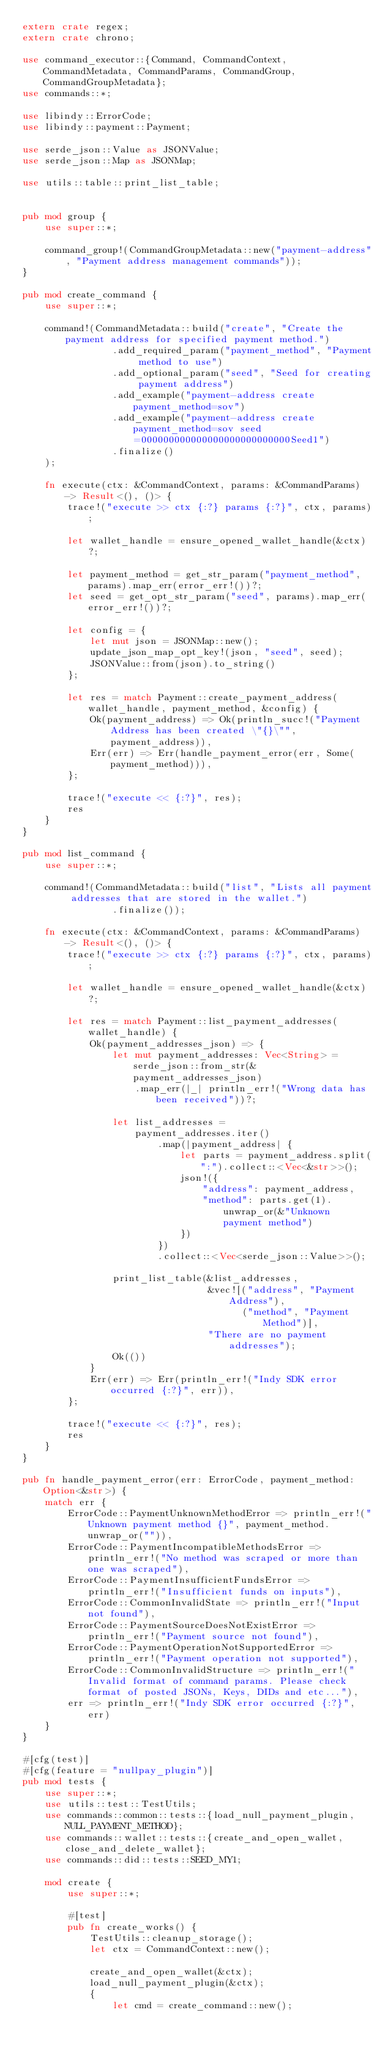Convert code to text. <code><loc_0><loc_0><loc_500><loc_500><_Rust_>extern crate regex;
extern crate chrono;

use command_executor::{Command, CommandContext, CommandMetadata, CommandParams, CommandGroup, CommandGroupMetadata};
use commands::*;

use libindy::ErrorCode;
use libindy::payment::Payment;

use serde_json::Value as JSONValue;
use serde_json::Map as JSONMap;

use utils::table::print_list_table;


pub mod group {
    use super::*;

    command_group!(CommandGroupMetadata::new("payment-address", "Payment address management commands"));
}

pub mod create_command {
    use super::*;

    command!(CommandMetadata::build("create", "Create the payment address for specified payment method.")
                .add_required_param("payment_method", "Payment method to use")
                .add_optional_param("seed", "Seed for creating payment address")
                .add_example("payment-address create payment_method=sov")
                .add_example("payment-address create payment_method=sov seed=000000000000000000000000000Seed1")
                .finalize()
    );

    fn execute(ctx: &CommandContext, params: &CommandParams) -> Result<(), ()> {
        trace!("execute >> ctx {:?} params {:?}", ctx, params);

        let wallet_handle = ensure_opened_wallet_handle(&ctx)?;

        let payment_method = get_str_param("payment_method", params).map_err(error_err!())?;
        let seed = get_opt_str_param("seed", params).map_err(error_err!())?;

        let config = {
            let mut json = JSONMap::new();
            update_json_map_opt_key!(json, "seed", seed);
            JSONValue::from(json).to_string()
        };

        let res = match Payment::create_payment_address(wallet_handle, payment_method, &config) {
            Ok(payment_address) => Ok(println_succ!("Payment Address has been created \"{}\"", payment_address)),
            Err(err) => Err(handle_payment_error(err, Some(payment_method))),
        };

        trace!("execute << {:?}", res);
        res
    }
}

pub mod list_command {
    use super::*;

    command!(CommandMetadata::build("list", "Lists all payment addresses that are stored in the wallet.")
                .finalize());

    fn execute(ctx: &CommandContext, params: &CommandParams) -> Result<(), ()> {
        trace!("execute >> ctx {:?} params {:?}", ctx, params);

        let wallet_handle = ensure_opened_wallet_handle(&ctx)?;

        let res = match Payment::list_payment_addresses(wallet_handle) {
            Ok(payment_addresses_json) => {
                let mut payment_addresses: Vec<String> = serde_json::from_str(&payment_addresses_json)
                    .map_err(|_| println_err!("Wrong data has been received"))?;

                let list_addresses =
                    payment_addresses.iter()
                        .map(|payment_address| {
                            let parts = payment_address.split(":").collect::<Vec<&str>>();
                            json!({
                                "address": payment_address,
                                "method": parts.get(1).unwrap_or(&"Unknown payment method")
                            })
                        })
                        .collect::<Vec<serde_json::Value>>();

                print_list_table(&list_addresses,
                                 &vec![("address", "Payment Address"),
                                       ("method", "Payment Method")],
                                 "There are no payment addresses");
                Ok(())
            }
            Err(err) => Err(println_err!("Indy SDK error occurred {:?}", err)),
        };

        trace!("execute << {:?}", res);
        res
    }
}

pub fn handle_payment_error(err: ErrorCode, payment_method: Option<&str>) {
    match err {
        ErrorCode::PaymentUnknownMethodError => println_err!("Unknown payment method {}", payment_method.unwrap_or("")),
        ErrorCode::PaymentIncompatibleMethodsError => println_err!("No method was scraped or more than one was scraped"),
        ErrorCode::PaymentInsufficientFundsError => println_err!("Insufficient funds on inputs"),
        ErrorCode::CommonInvalidState => println_err!("Input not found"),
        ErrorCode::PaymentSourceDoesNotExistError => println_err!("Payment source not found"),
        ErrorCode::PaymentOperationNotSupportedError => println_err!("Payment operation not supported"),
        ErrorCode::CommonInvalidStructure => println_err!("Invalid format of command params. Please check format of posted JSONs, Keys, DIDs and etc..."),
        err => println_err!("Indy SDK error occurred {:?}", err)
    }
}

#[cfg(test)]
#[cfg(feature = "nullpay_plugin")]
pub mod tests {
    use super::*;
    use utils::test::TestUtils;
    use commands::common::tests::{load_null_payment_plugin, NULL_PAYMENT_METHOD};
    use commands::wallet::tests::{create_and_open_wallet, close_and_delete_wallet};
    use commands::did::tests::SEED_MY1;

    mod create {
        use super::*;

        #[test]
        pub fn create_works() {
            TestUtils::cleanup_storage();
            let ctx = CommandContext::new();

            create_and_open_wallet(&ctx);
            load_null_payment_plugin(&ctx);
            {
                let cmd = create_command::new();</code> 